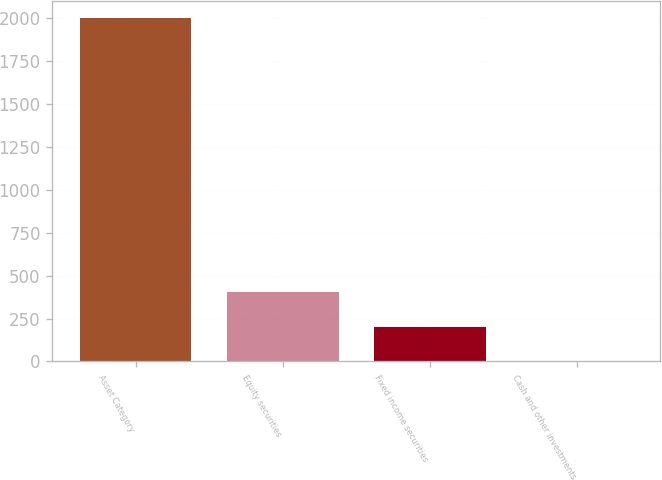<chart> <loc_0><loc_0><loc_500><loc_500><bar_chart><fcel>Asset Category<fcel>Equity securities<fcel>Fixed income securities<fcel>Cash and other investments<nl><fcel>2003<fcel>402.2<fcel>202.1<fcel>2<nl></chart> 